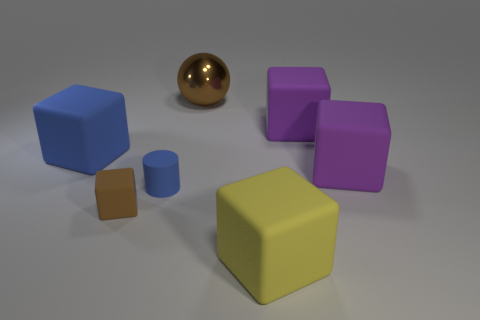Subtract all purple cubes. How many were subtracted if there are1purple cubes left? 1 Add 1 purple rubber things. How many objects exist? 8 Subtract all tiny blocks. How many blocks are left? 4 Subtract all spheres. How many objects are left? 6 Subtract all cyan cylinders. How many purple blocks are left? 2 Subtract all red blocks. Subtract all red balls. How many blocks are left? 5 Subtract all tiny rubber cubes. Subtract all big blue matte objects. How many objects are left? 5 Add 2 blue rubber cylinders. How many blue rubber cylinders are left? 3 Add 1 metallic things. How many metallic things exist? 2 Subtract all purple blocks. How many blocks are left? 3 